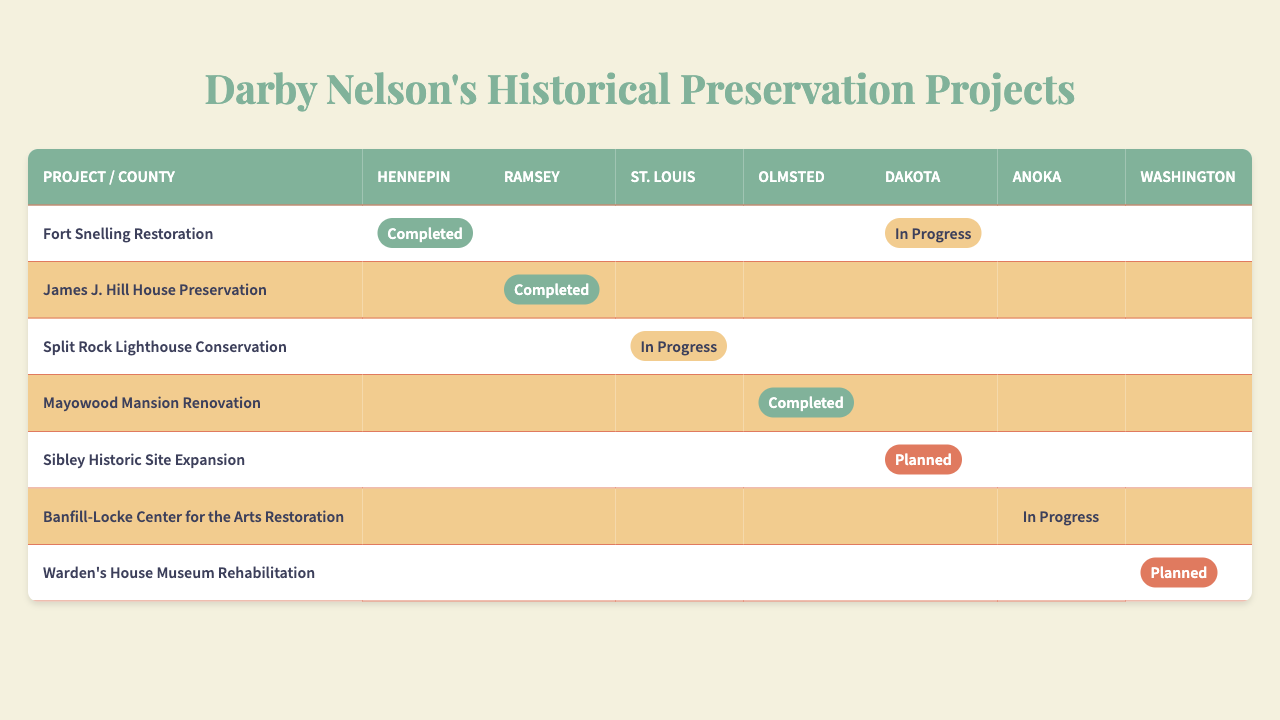What is the implementation status of the James J. Hill House Preservation in Ramsey County? The table shows that the status of the James J. Hill House Preservation project in Ramsey County is marked as "Completed."
Answer: Completed Which project related to historical preservation has been completed in Olmsted County? Looking at the table, the completed project in Olmsted County is the "Mayowood Mansion Renovation."
Answer: Mayowood Mansion Renovation How many counties have an "In Progress" status for any project? The table shows "In Progress" statuses in two counties: Dakota for "Fort Snelling Restoration" and Anoka for "Banfill-Locke Center for the Arts Restoration." Therefore, the number of counties is 2.
Answer: 2 Is there any county where the "Split Rock Lighthouse Conservation" project is marked as "Planned"? The table indicates that the "Split Rock Lighthouse Conservation" project does not have a "Planned" status in any county. Thus, the answer is no.
Answer: No What percentage of the projects are completed in Hennepin County? There is one completed project ("Fort Snelling Restoration") out of the seven total projects. To find the percentage: (1/7) * 100 = 14.29%.
Answer: 14.29% Which county has the most projects in progress? Anoka has one project "Banfill-Locke Center for the Arts Restoration" marked as "In Progress," while other counties with "In Progress" are Dakota and St. Louis, each with one. Hence, Anoka does not have the most; they are all tied at one.
Answer: No county has more than one in progress Are there any projects planned for Dakota County? The table shows that Dakota County has "Sibley Historic Site Expansion" listed as "Planned." Thus, there is a planned project.
Answer: Yes List all counties having a "Completed" status for any project. By examining the table, the completed statuses are found in Hennepin (Fort Snelling Restoration), Ramsey (James J. Hill House Preservation), and Olmsted (Mayowood Mansion Renovation). Therefore, the counties are Hennepin, Ramsey, and Olmsted.
Answer: Hennepin, Ramsey, Olmsted If we ignore the unimplemented projects, how many completed projects are there in total? Completed projects are indicated in the table as follows: "Fort Snelling Restoration," "James J. Hill House Preservation," and "Mayowood Mansion Renovation." So, there are 3 completed projects in total.
Answer: 3 What is the status of the Warden's House Museum Rehabilitation project in Washington County? In Washington County, the Warden's House Museum Rehabilitation project is marked as "Planned," according to the table.
Answer: Planned Which county has the "Sibley Historic Site Expansion" project planned, and what is its status? The table indicates that "Sibley Historic Site Expansion" is planned in Dakota County.
Answer: Dakota County, Planned 